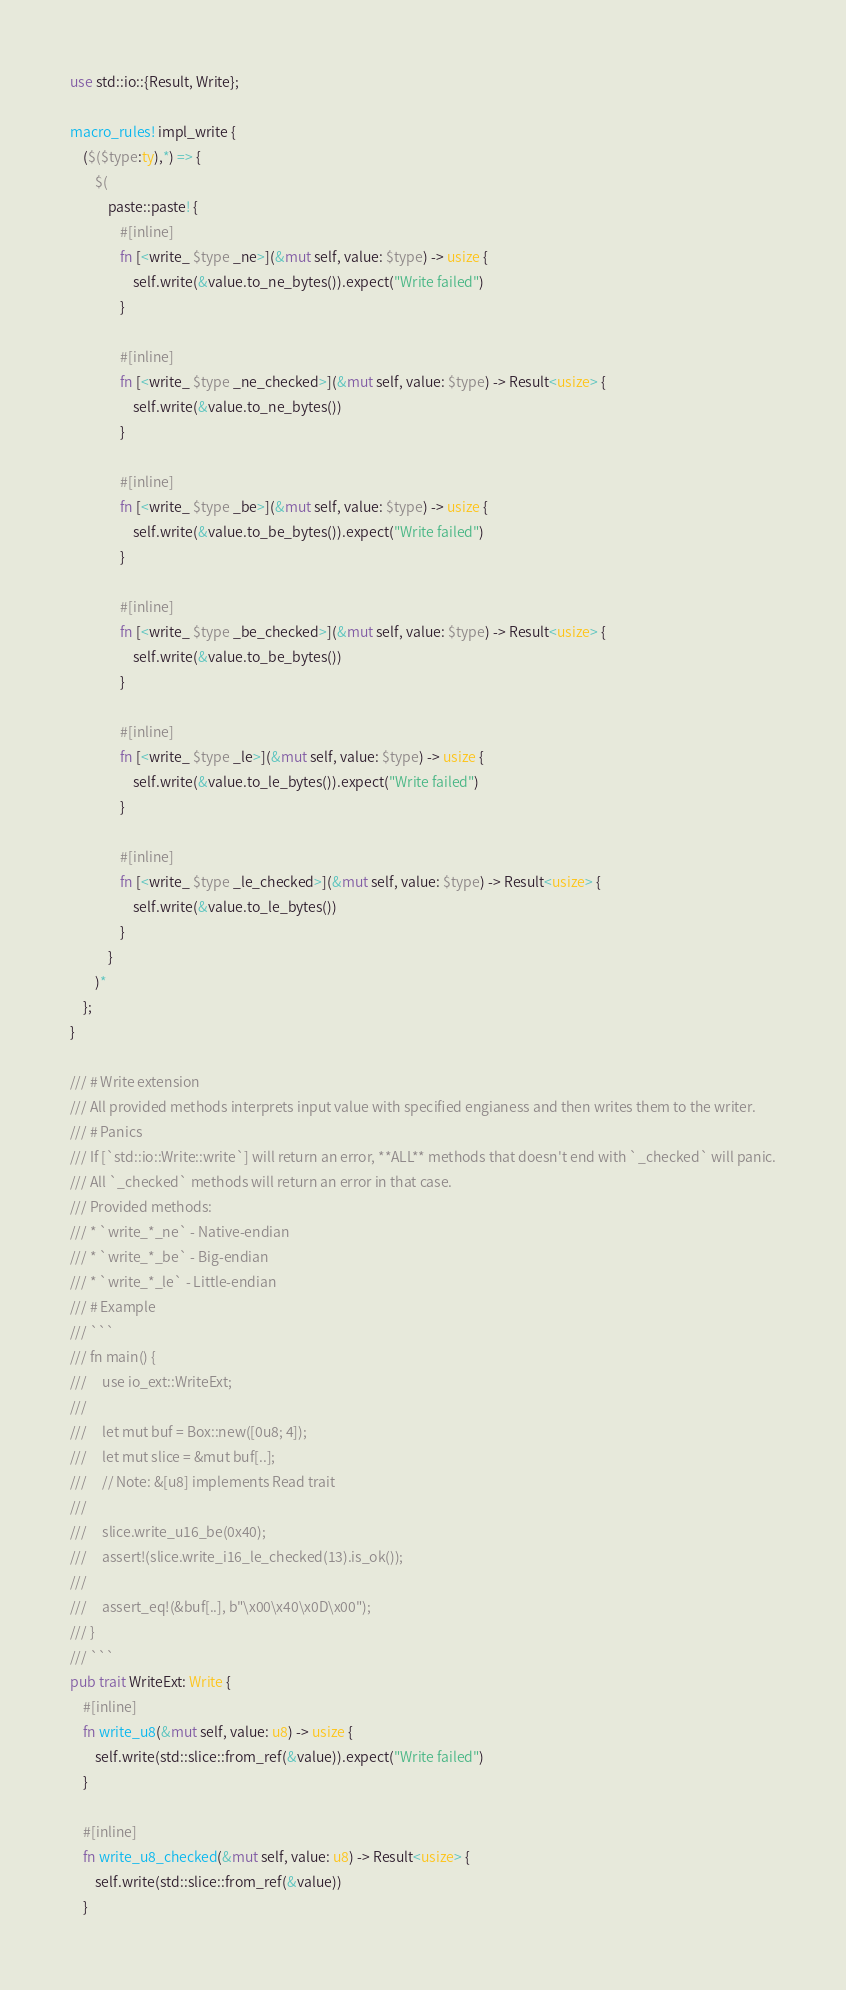Convert code to text. <code><loc_0><loc_0><loc_500><loc_500><_Rust_>use std::io::{Result, Write};

macro_rules! impl_write {
    ($($type:ty),*) => {
        $(
            paste::paste! {
                #[inline]
                fn [<write_ $type _ne>](&mut self, value: $type) -> usize {
                    self.write(&value.to_ne_bytes()).expect("Write failed")
                }

                #[inline]
                fn [<write_ $type _ne_checked>](&mut self, value: $type) -> Result<usize> {
                    self.write(&value.to_ne_bytes())
                }

                #[inline]
                fn [<write_ $type _be>](&mut self, value: $type) -> usize {
                    self.write(&value.to_be_bytes()).expect("Write failed")
                }

                #[inline]
                fn [<write_ $type _be_checked>](&mut self, value: $type) -> Result<usize> {
                    self.write(&value.to_be_bytes())
                }

                #[inline]
                fn [<write_ $type _le>](&mut self, value: $type) -> usize {
                    self.write(&value.to_le_bytes()).expect("Write failed")
                }

                #[inline]
                fn [<write_ $type _le_checked>](&mut self, value: $type) -> Result<usize> {
                    self.write(&value.to_le_bytes())
                }
            }
        )*
    };
}

/// # Write extension
/// All provided methods interprets input value with specified engianess and then writes them to the writer.
/// # Panics
/// If [`std::io::Write::write`] will return an error, **ALL** methods that doesn't end with `_checked` will panic.
/// All `_checked` methods will return an error in that case.
/// Provided methods:
/// * `write_*_ne` - Native-endian
/// * `write_*_be` - Big-endian
/// * `write_*_le` - Little-endian
/// # Example
/// ```
/// fn main() {
///     use io_ext::WriteExt;
///     
///     let mut buf = Box::new([0u8; 4]);
///     let mut slice = &mut buf[..];
///     // Note: &[u8] implements Read trait
/// 
///     slice.write_u16_be(0x40);
///     assert!(slice.write_i16_le_checked(13).is_ok());
/// 
///     assert_eq!(&buf[..], b"\x00\x40\x0D\x00");
/// }
/// ```
pub trait WriteExt: Write {
    #[inline]
    fn write_u8(&mut self, value: u8) -> usize {
        self.write(std::slice::from_ref(&value)).expect("Write failed")
    }

    #[inline]
    fn write_u8_checked(&mut self, value: u8) -> Result<usize> {
        self.write(std::slice::from_ref(&value))
    }
</code> 